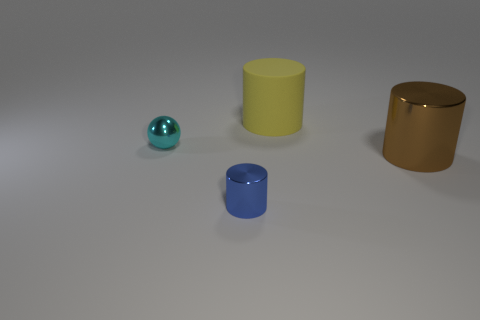Is there anything else that is made of the same material as the yellow cylinder?
Your answer should be compact. No. Are there the same number of big metallic objects in front of the brown shiny object and big brown matte things?
Make the answer very short. Yes. How many things are tiny metallic objects that are behind the big metallic cylinder or big matte objects?
Make the answer very short. 2. There is a object that is to the left of the large yellow matte cylinder and behind the large brown cylinder; what is its shape?
Ensure brevity in your answer.  Sphere. How many things are either blue cylinders left of the large yellow matte cylinder or big cylinders that are behind the brown cylinder?
Ensure brevity in your answer.  2. What number of other things are there of the same size as the blue thing?
Provide a short and direct response. 1. What is the size of the object that is both on the right side of the small blue cylinder and in front of the yellow cylinder?
Make the answer very short. Large. How many big objects are blue shiny objects or blue shiny blocks?
Your answer should be very brief. 0. There is a tiny thing in front of the brown object; what shape is it?
Provide a succinct answer. Cylinder. What number of cyan rubber blocks are there?
Provide a short and direct response. 0. 